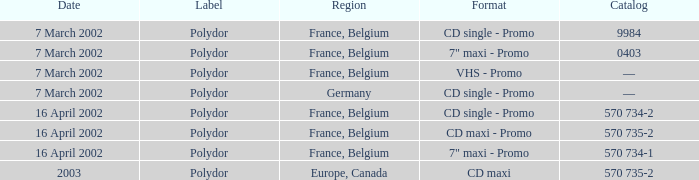Which region had a catalog number of 570 734-2? France, Belgium. 